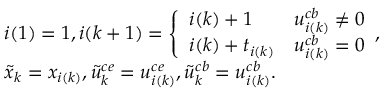Convert formula to latex. <formula><loc_0><loc_0><loc_500><loc_500>\begin{array} { r l } & { i ( 1 ) = 1 , i ( k + 1 ) = \left \{ \begin{array} { l l } { i ( k ) + 1 } & { { u } _ { i ( k ) } ^ { c b } \neq 0 } \\ { i ( k ) + t _ { i ( k ) } } & { { u } _ { i ( k ) } ^ { c b } = 0 } \end{array} , } \\ & { \tilde { x } _ { k } = x _ { i ( k ) } , \tilde { u } _ { k } ^ { c e } = u _ { i ( k ) } ^ { c e } , \tilde { u } _ { k } ^ { c b } = u _ { i ( k ) } ^ { c b } . } \end{array}</formula> 